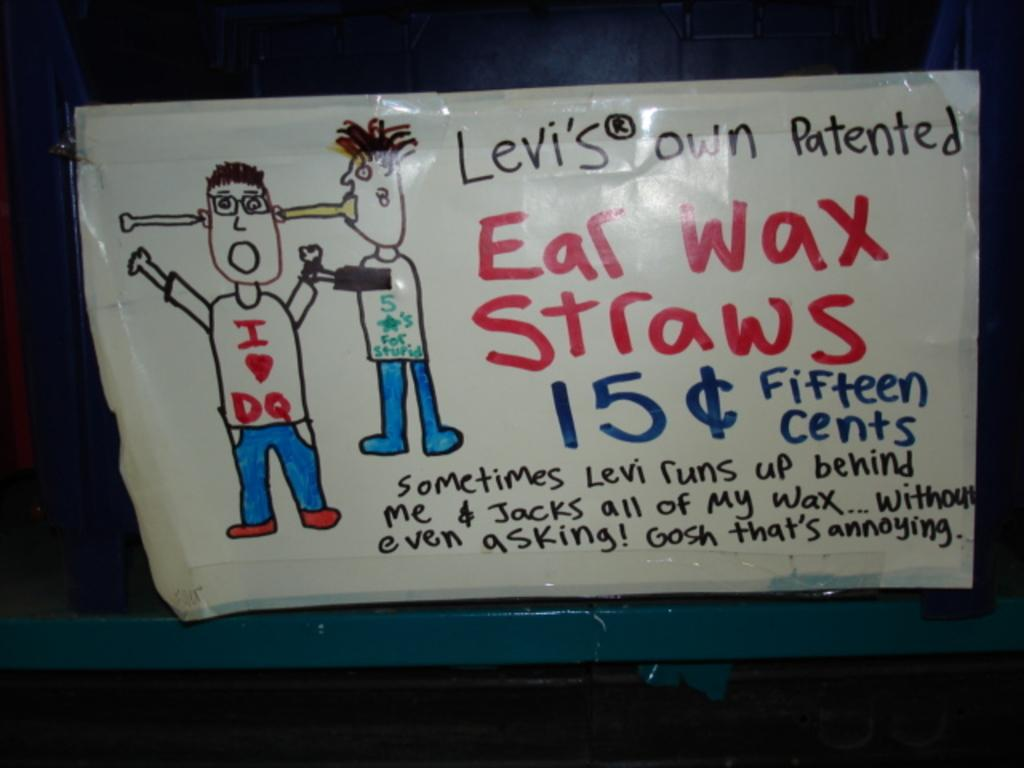What is the main subject of the image? The main subject of the image is a poster. What is depicted on the poster? The poster contains a depiction of persons. Are there any words on the poster? Yes, the poster contains some text. What type of magic is being performed by the persons on the poster? There is no indication of magic or any performance in the image; it only shows a poster with a depiction of persons and some text. 